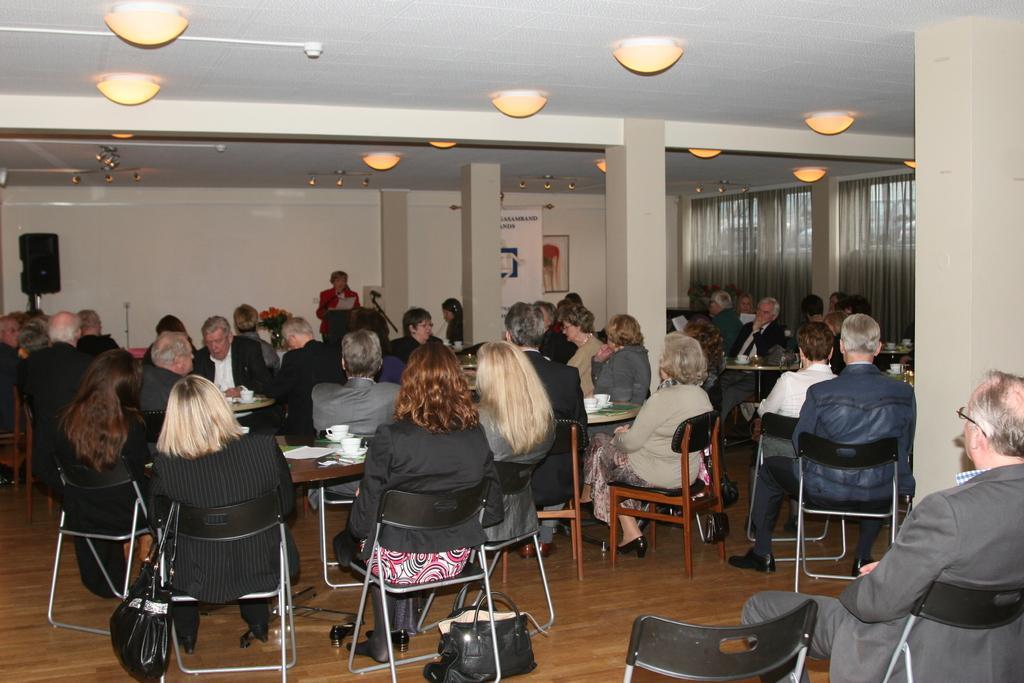In one or two sentences, can you explain what this image depicts? There are many people sitting on the chairs. And to the left corner there is a speaker. And in front of the people there is a lady standing in front of the podium. And there are three pillars. And there are some curtains. And on the top there are light. 